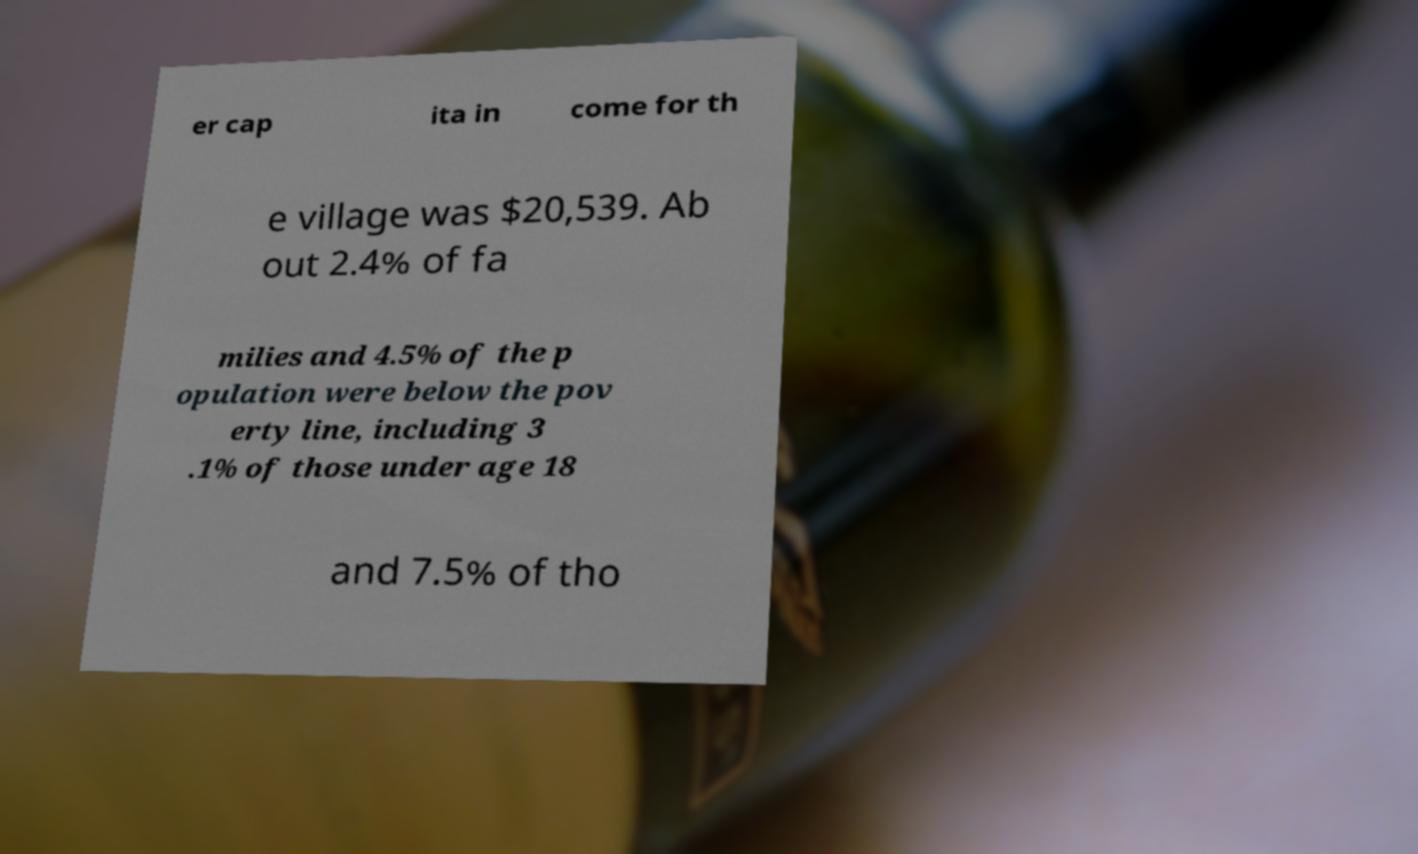Can you read and provide the text displayed in the image?This photo seems to have some interesting text. Can you extract and type it out for me? er cap ita in come for th e village was $20,539. Ab out 2.4% of fa milies and 4.5% of the p opulation were below the pov erty line, including 3 .1% of those under age 18 and 7.5% of tho 